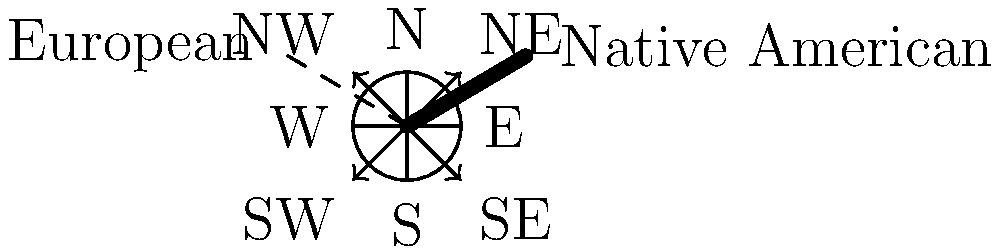In the diagram, European compass directions are represented by solid lines, while Native American cardinal directions are shown with dashed arrows. What is the angular difference between the European "North" and the Native American "Northeast" direction? To find the angular difference between European "North" and Native American "Northeast":

1. European "North" is represented by the vertical line pointing upwards (0°).
2. Native American "Northeast" is shown by the dashed arrow in the upper-right quadrant.
3. In a standard compass, Northeast is at 45° from North.
4. The angle between two adjacent cardinal directions in the European system is 90°.
5. The Native American system divides this 90° angle into two equal parts.
6. Therefore, the Native American "Northeast" bisects the angle between European "North" and "East".
7. The angular difference is thus half of 90°, which is 45°.
Answer: 45° 